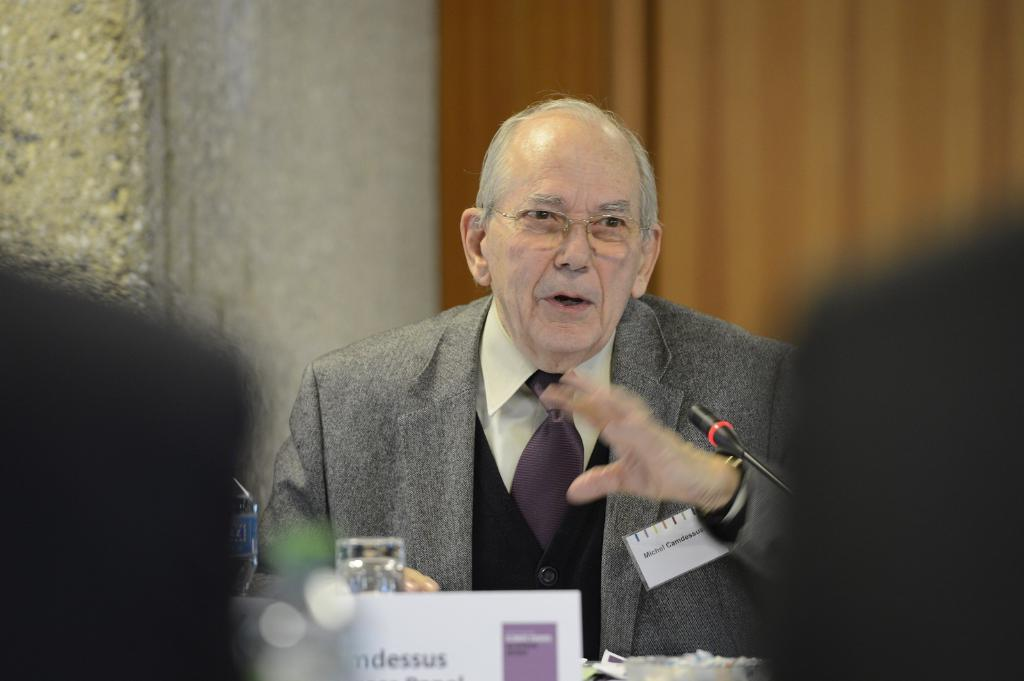<image>
Relay a brief, clear account of the picture shown. Man speaking into a microphone whose name is Michel. 